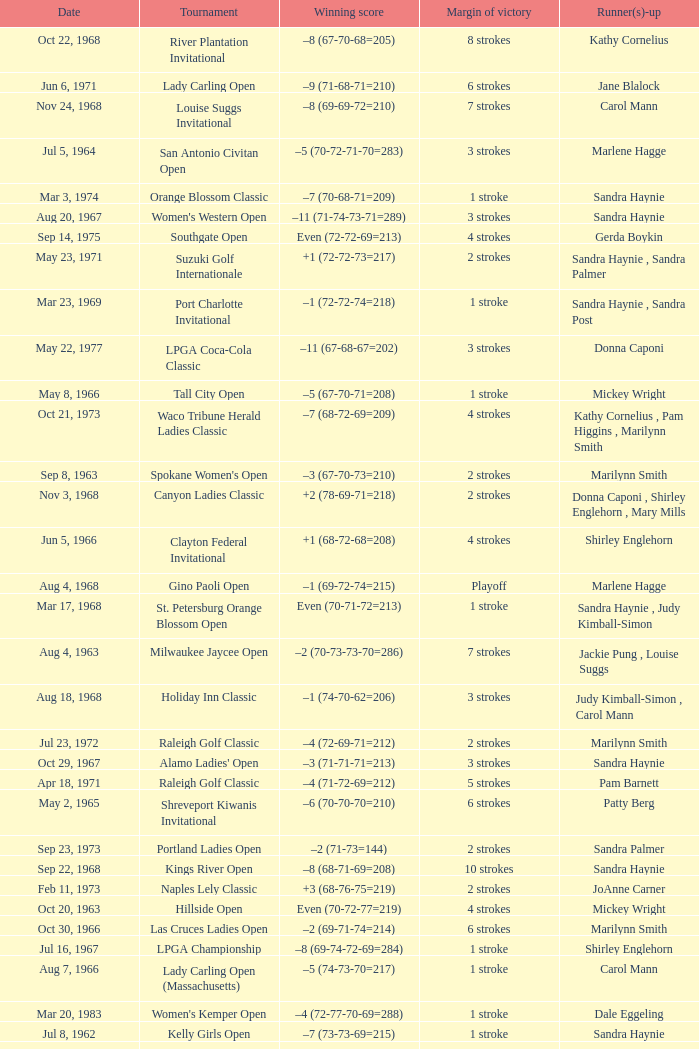Parse the full table. {'header': ['Date', 'Tournament', 'Winning score', 'Margin of victory', 'Runner(s)-up'], 'rows': [['Oct 22, 1968', 'River Plantation Invitational', '–8 (67-70-68=205)', '8 strokes', 'Kathy Cornelius'], ['Jun 6, 1971', 'Lady Carling Open', '–9 (71-68-71=210)', '6 strokes', 'Jane Blalock'], ['Nov 24, 1968', 'Louise Suggs Invitational', '–8 (69-69-72=210)', '7 strokes', 'Carol Mann'], ['Jul 5, 1964', 'San Antonio Civitan Open', '–5 (70-72-71-70=283)', '3 strokes', 'Marlene Hagge'], ['Mar 3, 1974', 'Orange Blossom Classic', '–7 (70-68-71=209)', '1 stroke', 'Sandra Haynie'], ['Aug 20, 1967', "Women's Western Open", '–11 (71-74-73-71=289)', '3 strokes', 'Sandra Haynie'], ['Sep 14, 1975', 'Southgate Open', 'Even (72-72-69=213)', '4 strokes', 'Gerda Boykin'], ['May 23, 1971', 'Suzuki Golf Internationale', '+1 (72-72-73=217)', '2 strokes', 'Sandra Haynie , Sandra Palmer'], ['Mar 23, 1969', 'Port Charlotte Invitational', '–1 (72-72-74=218)', '1 stroke', 'Sandra Haynie , Sandra Post'], ['May 22, 1977', 'LPGA Coca-Cola Classic', '–11 (67-68-67=202)', '3 strokes', 'Donna Caponi'], ['May 8, 1966', 'Tall City Open', '–5 (67-70-71=208)', '1 stroke', 'Mickey Wright'], ['Oct 21, 1973', 'Waco Tribune Herald Ladies Classic', '–7 (68-72-69=209)', '4 strokes', 'Kathy Cornelius , Pam Higgins , Marilynn Smith'], ['Sep 8, 1963', "Spokane Women's Open", '–3 (67-70-73=210)', '2 strokes', 'Marilynn Smith'], ['Nov 3, 1968', 'Canyon Ladies Classic', '+2 (78-69-71=218)', '2 strokes', 'Donna Caponi , Shirley Englehorn , Mary Mills'], ['Jun 5, 1966', 'Clayton Federal Invitational', '+1 (68-72-68=208)', '4 strokes', 'Shirley Englehorn'], ['Aug 4, 1968', 'Gino Paoli Open', '–1 (69-72-74=215)', 'Playoff', 'Marlene Hagge'], ['Mar 17, 1968', 'St. Petersburg Orange Blossom Open', 'Even (70-71-72=213)', '1 stroke', 'Sandra Haynie , Judy Kimball-Simon'], ['Aug 4, 1963', 'Milwaukee Jaycee Open', '–2 (70-73-73-70=286)', '7 strokes', 'Jackie Pung , Louise Suggs'], ['Aug 18, 1968', 'Holiday Inn Classic', '–1 (74-70-62=206)', '3 strokes', 'Judy Kimball-Simon , Carol Mann'], ['Jul 23, 1972', 'Raleigh Golf Classic', '–4 (72-69-71=212)', '2 strokes', 'Marilynn Smith'], ['Oct 29, 1967', "Alamo Ladies' Open", '–3 (71-71-71=213)', '3 strokes', 'Sandra Haynie'], ['Apr 18, 1971', 'Raleigh Golf Classic', '–4 (71-72-69=212)', '5 strokes', 'Pam Barnett'], ['May 2, 1965', 'Shreveport Kiwanis Invitational', '–6 (70-70-70=210)', '6 strokes', 'Patty Berg'], ['Sep 23, 1973', 'Portland Ladies Open', '–2 (71-73=144)', '2 strokes', 'Sandra Palmer'], ['Sep 22, 1968', 'Kings River Open', '–8 (68-71-69=208)', '10 strokes', 'Sandra Haynie'], ['Feb 11, 1973', 'Naples Lely Classic', '+3 (68-76-75=219)', '2 strokes', 'JoAnne Carner'], ['Oct 20, 1963', 'Hillside Open', 'Even (70-72-77=219)', '4 strokes', 'Mickey Wright'], ['Oct 30, 1966', 'Las Cruces Ladies Open', '–2 (69-71-74=214)', '6 strokes', 'Marilynn Smith'], ['Jul 16, 1967', 'LPGA Championship', '–8 (69-74-72-69=284)', '1 stroke', 'Shirley Englehorn'], ['Aug 7, 1966', 'Lady Carling Open (Massachusetts)', '–5 (74-73-70=217)', '1 stroke', 'Carol Mann'], ['Mar 20, 1983', "Women's Kemper Open", '–4 (72-77-70-69=288)', '1 stroke', 'Dale Eggeling'], ['Jul 8, 1962', 'Kelly Girls Open', '–7 (73-73-69=215)', '1 stroke', 'Sandra Haynie'], ['Aug 1, 1965', 'Lady Carling Midwest Open', 'Even (72-77-70=219)', '1 stroke', 'Sandra Haynie'], ['Jul 28, 1963', 'Wolverine Open', '–9 (72-64-62=198)', '5 strokes', 'Betsy Rawls'], ['Apr 18, 1982', "CPC Women's International", '–7 (73-68-73-67=281)', '9 strokes', 'Patty Sheehan'], ['Aug 6, 1972', 'Knoxville Ladies Classic', '–4 (71-68-71=210)', '4 strokes', 'Sandra Haynie'], ['Sep 16, 1973', 'Southgate Ladies Open', '–2 (72-70=142)', '1 stroke', 'Gerda Boykin'], ['Jun 15, 1969', 'Patty Berg Classic', '–5 (69-73-72=214)', '1 stroke', 'Sandra Haynie'], ['Jun 19, 1966', 'Milwaukee Jaycee Open', '–7 (68-71-69-65=273)', '12 strokes', 'Sandra Haynie'], ['Apr 3, 1977', "Colgate-Dinah Shore Winner's Circle", '+1 (76-70-72-71=289)', '1 stroke', 'Joanne Carner , Sally Little'], ['Oct 14, 1984', 'Smirnoff Ladies Irish Open', '–3 (70-74-69-72=285)', '2 strokes', 'Pat Bradley , Becky Pearson'], ['Jun 30, 1963', 'Carvel Ladies Open', '–2 (72-74-71=217)', '1 stroke', 'Marilynn Smith'], ['Mar 22, 1970', 'Orange Blossom Classic', '+3 (73-72-71=216)', '1 stroke', 'Carol Mann'], ['Nov 4, 1973', 'Lady Errol Classic', '–3 (68-75-70=213)', '2 strokes', 'Gloria Ehret , Shelley Hamlin'], ['Sep 10, 1978', 'National Jewish Hospital Open', '–5 (70-75-66-65=276)', '3 strokes', 'Pat Bradley , Gloria Ehret , JoAnn Washam'], ['May 12, 1985', 'United Virginia Bank Classic', '–9 (69-66-72=207)', '1 stroke', 'Amy Alcott'], ['Nov 27, 1966', 'Titleholders Championship', '+3 (74-70-74-73=291)', '2 strokes', 'Judy Kimball-Simon , Mary Mills'], ['Feb 7, 1976', 'Bent Tree Classic', '–7 (69-69-71=209)', '1 stroke', 'Hollis Stacy'], ['Oct 1, 1967', "Ladies' Los Angeles Open", '–4 (71-68-73=212)', '4 strokes', 'Murle Breer'], ['Jul 18, 1965', 'Yankee Open', '–3 (73-68-72=213)', '2 strokes', 'Carol Mann'], ['Mar 30, 1969', 'Port Malabar Invitational', '–3 (68-72-70=210)', '4 strokes', 'Mickey Wright'], ['Jun 30, 1968', 'Lady Carling Open (Maryland)', '–2 (71-70-73=214)', '1 stroke', 'Carol Mann'], ['Apr 23, 1967', 'Raleigh Ladies Invitational', '–1 (72-72-71=215)', '5 strokes', 'Susie Maxwell Berning'], ['Sep 16, 1984', 'Safeco Classic', '–9 (69-75-65-70=279)', '2 strokes', 'Laura Baugh , Marta Figueras-Dotti'], ['May 26, 1968', 'Dallas Civitan Open', '–4 (70-70-69=209)', '1 stroke', 'Carol Mann'], ['Sep 9, 1973', 'Dallas Civitan Open', '–3 (75-72-66=213)', 'Playoff', 'Mary Mills'], ['Mar 11, 1973', 'S&H Green Stamp Classic', '–2 (73-71-70=214)', '2 strokes', 'Mary Mills'], ['Jul 25, 1965', 'Buckeye Savings Invitational', '–6 (70-67-70=207)', '1 stroke', 'Susan Maxwell-Berning'], ['Oct 14, 1962', 'Phoenix Thunderbird Open', '–3 (72-71-70=213)', '4 strokes', 'Mickey Wright'], ['Apr 30, 1972', 'Alamo Ladies Open', '–10 (66-71-72=209)', '3 strokes', 'Mickey Wright'], ['Jul 22, 1984', 'Rochester International', '–7 (73-68-71-69=281)', 'Playoff', 'Rosie Jones'], ['Aug 6, 1967', 'Lady Carling Open (Ohio)', '–4 (71-70-71=212)', '1 stroke', 'Susie Maxwell Berning'], ['Nov 6, 1966', "Amarillo Ladies' Open", '+2 (76-71-68=215)', 'Playoff', 'Mickey Wright'], ['Mar 17, 1969', 'Orange Blossom Classic', '+3 (74-70-72=216)', 'Playoff', 'Shirley Englehorn , Marlene Hagge'], ['May 16, 1982', 'Lady Michelob', '–9 (69-68-70=207)', '4 strokes', 'Sharon Barrett Barbara Moxness'], ['Aug 20, 1972', 'Southgate Ladies Open', 'Even (69-71-76=216)', 'Playoff', 'Jocelyne Bourassa'], ['Apr 24, 1977', 'American Defender Classic', '–10 (69-68-69=206)', '1 stroke', 'Pat Bradley'], ['Jul 30, 1966', 'Supertest Ladies Open', '–3 (71-70-72=213)', '3 strokes', 'Mickey Wright'], ['Nov 10, 1963', 'San Antonio Civitan Open', '+7 (73-73-78-75=299)', 'Playoff', 'Mickey Wright'], ['Aug 25, 1963', "Ogden Ladies' Open", '–5 (69-75-71=215)', '5 strokes', 'Mickey Wright'], ['Jun 6, 1965', 'Blue Grass Invitational', '–3 (70-69-74=213)', '4 strokes', 'Clifford Ann Creed'], ['May 17, 1981', 'Coca-Cola Classic', '–8 (69-72-70=211)', 'Playoff', 'Alice Ritzman'], ['Jun 1, 1975', 'LPGA Championship', '–4 (70-70-75-73=288)', '1 stroke', 'Sandra Haynie'], ['Oct 1, 1972', 'Portland Ladies Open', '–7 (75-69-68=212)', '4 strokes', 'Sandra Haynie'], ['Jun 7, 1967', "St. Louis Women's Invitational", '+2 (68-70-71=209)', '2 strokes', 'Carol Mann'], ['Aug 13, 1966', 'Lady Carling Open (Maryland)', '–2 (70-71-73=214)', '3 strokes', 'Peggy Wilson'], ['Sep 14, 1969', 'Wendell-West Open', '–3 (69-72-72=213)', '1 stroke', 'Judy Rankin'], ['Aug 22, 1976', 'Patty Berg Classic', '–7 (66-73-73=212)', '2 strokes', 'Sandra Post'], ['Jun 13, 1971', 'Eve-LPGA Championship', '–4 (71-73-70-74=288)', '4 strokes', 'Kathy Ahern'], ['Mar 21, 1965', 'St. Petersburg Open', '–7 (70-66-71-74=281)', '4 strokes', 'Sandra Haynie'], ['Oct 18, 1970', "Quality Chek'd Classic", '–11 (71-67-67=205)', '3 strokes', 'JoAnne Carner'], ['Apr 20, 1969', 'Lady Carling Open (Georgia)', '–4 (70-72-70=212)', 'Playoff', 'Mickey Wright'], ['Mar 26, 1967', 'Venice Ladies Open', '+4 (70-71-76=217)', '1 stroke', 'Clifford Ann Creed , Gloria Ehret'], ['Nov 28, 1965', 'Titleholders Championship', '–1 (71-71-74-71=287)', '10 strokes', 'Peggy Wilson'], ['Nov 17, 1968', 'Pensacola Ladies Invitational', '–3 (71-71-74=216)', '3 strokes', 'Jo Ann Prentice ,'], ['Nov 17, 1963', 'Mary Mills Mississippi Gulf Coast Invitational', 'Even (72-77-70=219)', '4 strokes', 'Mickey Wright'], ['Oct 3, 1965', 'Mickey Wright Invitational', '–9 (68-73-71-71=283)', '6 strokes', 'Donna Caponi'], ['Nov 2, 1969', "River Plantation Women's Open", 'Even (70-71-72=213)', '1 stroke', 'Betsy Rawls']]} What was the margin of victory on Apr 23, 1967? 5 strokes. 